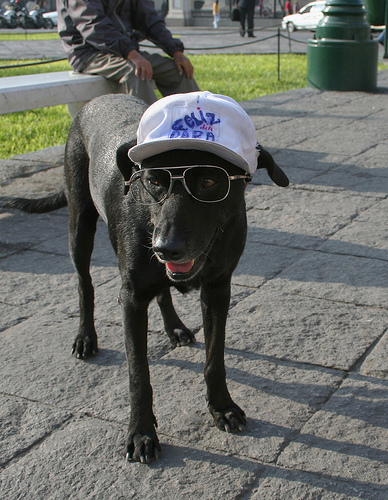How many different kinds of animals are in the photo? 1 